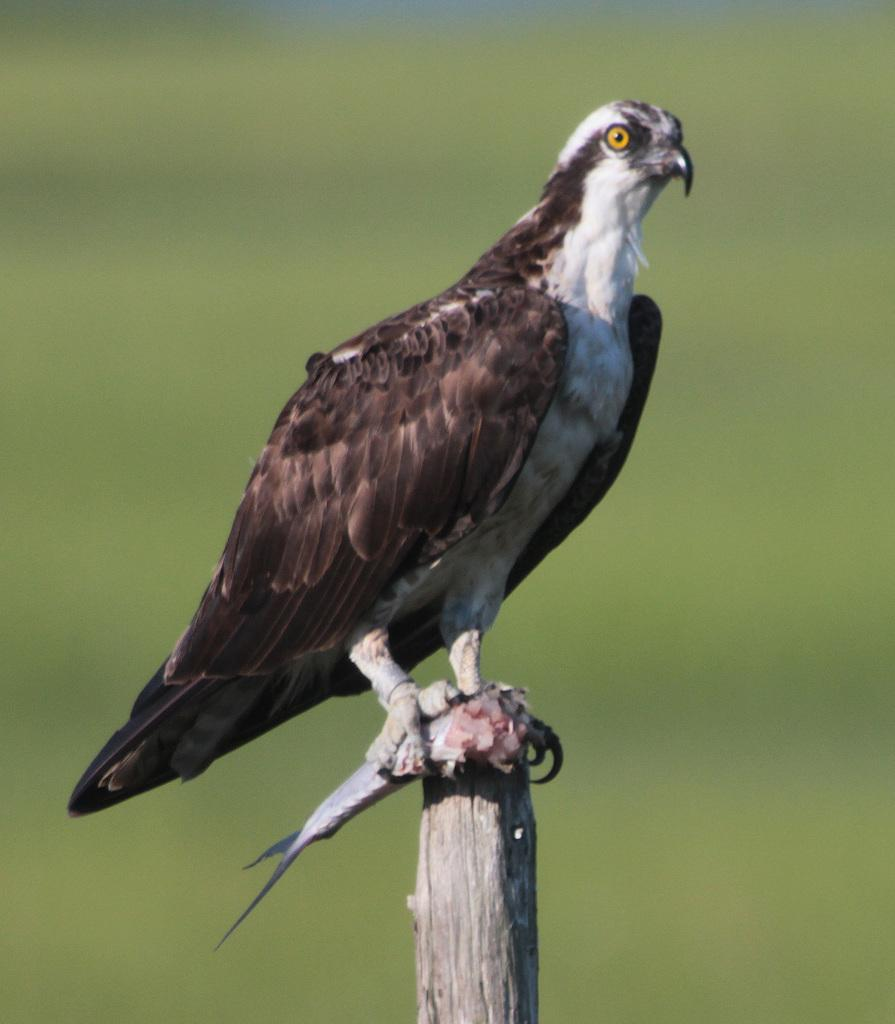What type of animal is in the image? There is a bird in the image. Where is the bird located? The bird is on a pole. What is the bird holding? The bird is holding a fish. Can you describe the background of the image? The background of the image is blurry. How many giraffes can be seen in the image? There are no giraffes present in the image. What letters are visible on the bird's wings? The bird does not have letters on its wings, as it is a real bird and not a toy or decorated bird. 